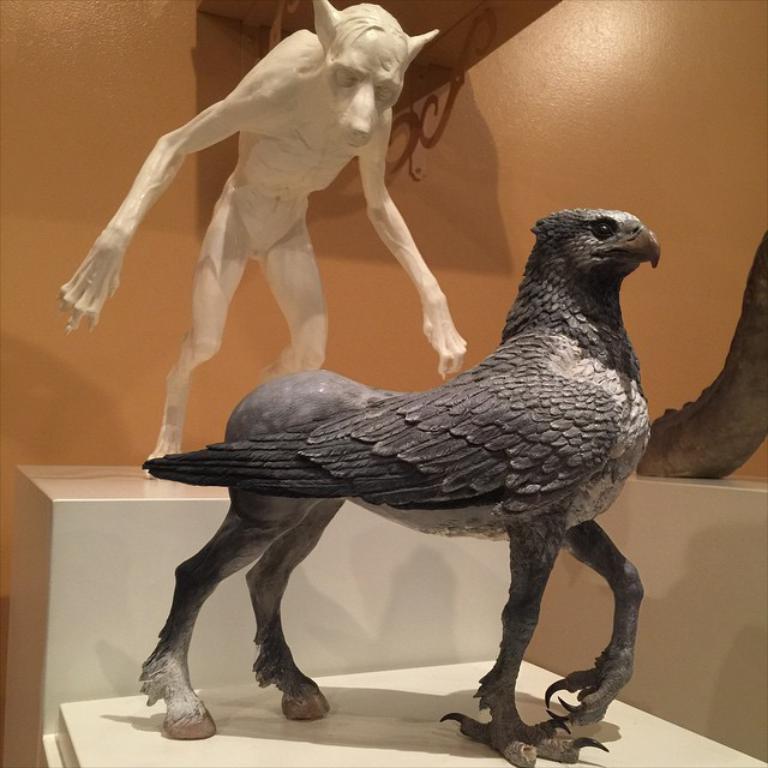How would you summarize this image in a sentence or two? In this picture, we can see a few statues on an object, we can see the wall. 